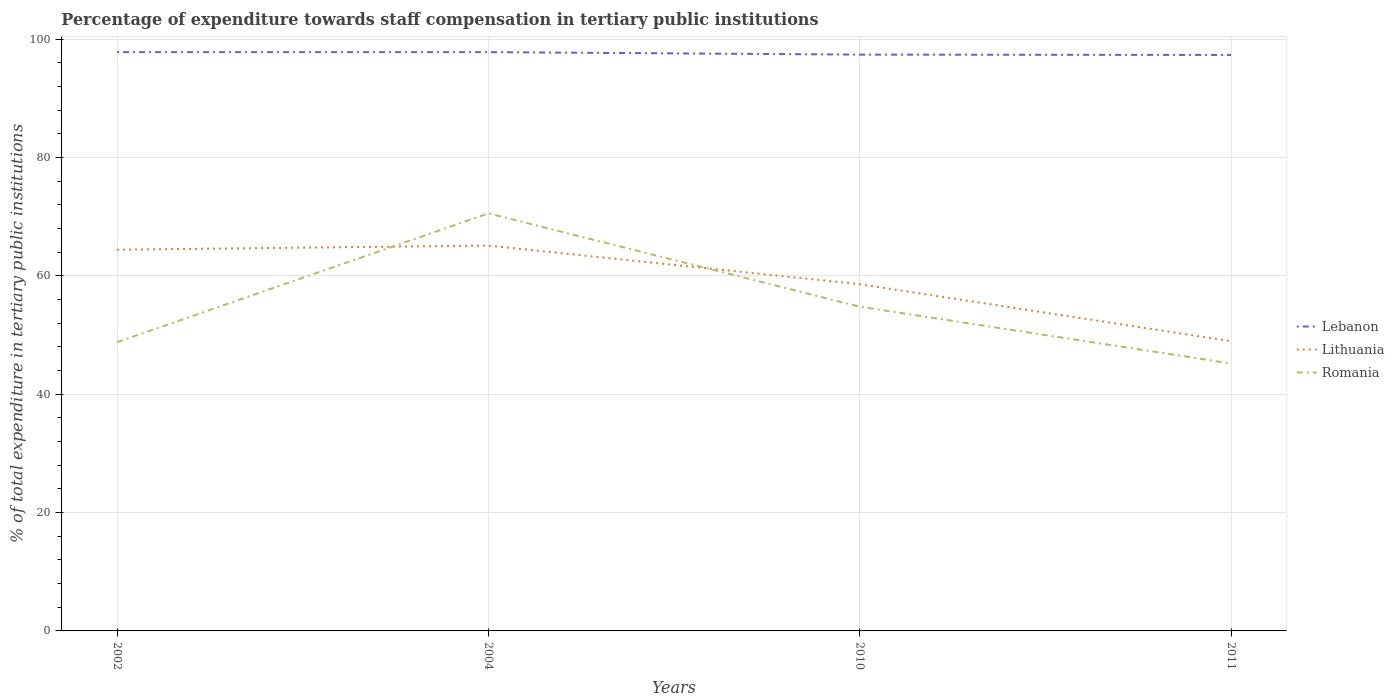Across all years, what is the maximum percentage of expenditure towards staff compensation in Lithuania?
Keep it short and to the point. 48.96. In which year was the percentage of expenditure towards staff compensation in Lithuania maximum?
Keep it short and to the point. 2011. What is the total percentage of expenditure towards staff compensation in Lithuania in the graph?
Offer a terse response. 16.15. What is the difference between the highest and the second highest percentage of expenditure towards staff compensation in Romania?
Keep it short and to the point. 25.36. What is the difference between the highest and the lowest percentage of expenditure towards staff compensation in Lithuania?
Offer a very short reply. 2. Is the percentage of expenditure towards staff compensation in Lithuania strictly greater than the percentage of expenditure towards staff compensation in Lebanon over the years?
Keep it short and to the point. Yes. How many lines are there?
Your response must be concise. 3. Are the values on the major ticks of Y-axis written in scientific E-notation?
Your response must be concise. No. Does the graph contain any zero values?
Your response must be concise. No. How many legend labels are there?
Offer a terse response. 3. What is the title of the graph?
Keep it short and to the point. Percentage of expenditure towards staff compensation in tertiary public institutions. What is the label or title of the Y-axis?
Your response must be concise. % of total expenditure in tertiary public institutions. What is the % of total expenditure in tertiary public institutions of Lebanon in 2002?
Make the answer very short. 97.8. What is the % of total expenditure in tertiary public institutions of Lithuania in 2002?
Provide a short and direct response. 64.41. What is the % of total expenditure in tertiary public institutions of Romania in 2002?
Give a very brief answer. 48.79. What is the % of total expenditure in tertiary public institutions of Lebanon in 2004?
Keep it short and to the point. 97.8. What is the % of total expenditure in tertiary public institutions in Lithuania in 2004?
Ensure brevity in your answer.  65.11. What is the % of total expenditure in tertiary public institutions in Romania in 2004?
Your answer should be compact. 70.56. What is the % of total expenditure in tertiary public institutions of Lebanon in 2010?
Keep it short and to the point. 97.38. What is the % of total expenditure in tertiary public institutions in Lithuania in 2010?
Make the answer very short. 58.59. What is the % of total expenditure in tertiary public institutions of Romania in 2010?
Provide a succinct answer. 54.79. What is the % of total expenditure in tertiary public institutions of Lebanon in 2011?
Make the answer very short. 97.32. What is the % of total expenditure in tertiary public institutions in Lithuania in 2011?
Provide a short and direct response. 48.96. What is the % of total expenditure in tertiary public institutions of Romania in 2011?
Your answer should be very brief. 45.19. Across all years, what is the maximum % of total expenditure in tertiary public institutions of Lebanon?
Provide a short and direct response. 97.8. Across all years, what is the maximum % of total expenditure in tertiary public institutions of Lithuania?
Your response must be concise. 65.11. Across all years, what is the maximum % of total expenditure in tertiary public institutions of Romania?
Give a very brief answer. 70.56. Across all years, what is the minimum % of total expenditure in tertiary public institutions in Lebanon?
Provide a short and direct response. 97.32. Across all years, what is the minimum % of total expenditure in tertiary public institutions of Lithuania?
Offer a very short reply. 48.96. Across all years, what is the minimum % of total expenditure in tertiary public institutions in Romania?
Provide a succinct answer. 45.19. What is the total % of total expenditure in tertiary public institutions in Lebanon in the graph?
Keep it short and to the point. 390.3. What is the total % of total expenditure in tertiary public institutions in Lithuania in the graph?
Provide a short and direct response. 237.07. What is the total % of total expenditure in tertiary public institutions in Romania in the graph?
Provide a short and direct response. 219.33. What is the difference between the % of total expenditure in tertiary public institutions of Lebanon in 2002 and that in 2004?
Offer a very short reply. -0. What is the difference between the % of total expenditure in tertiary public institutions of Lithuania in 2002 and that in 2004?
Offer a very short reply. -0.7. What is the difference between the % of total expenditure in tertiary public institutions in Romania in 2002 and that in 2004?
Give a very brief answer. -21.76. What is the difference between the % of total expenditure in tertiary public institutions in Lebanon in 2002 and that in 2010?
Your answer should be compact. 0.42. What is the difference between the % of total expenditure in tertiary public institutions in Lithuania in 2002 and that in 2010?
Keep it short and to the point. 5.82. What is the difference between the % of total expenditure in tertiary public institutions in Romania in 2002 and that in 2010?
Make the answer very short. -5.99. What is the difference between the % of total expenditure in tertiary public institutions in Lebanon in 2002 and that in 2011?
Provide a succinct answer. 0.47. What is the difference between the % of total expenditure in tertiary public institutions of Lithuania in 2002 and that in 2011?
Offer a terse response. 15.46. What is the difference between the % of total expenditure in tertiary public institutions of Romania in 2002 and that in 2011?
Offer a terse response. 3.6. What is the difference between the % of total expenditure in tertiary public institutions in Lebanon in 2004 and that in 2010?
Keep it short and to the point. 0.42. What is the difference between the % of total expenditure in tertiary public institutions of Lithuania in 2004 and that in 2010?
Your answer should be very brief. 6.52. What is the difference between the % of total expenditure in tertiary public institutions of Romania in 2004 and that in 2010?
Offer a very short reply. 15.77. What is the difference between the % of total expenditure in tertiary public institutions of Lebanon in 2004 and that in 2011?
Offer a very short reply. 0.47. What is the difference between the % of total expenditure in tertiary public institutions of Lithuania in 2004 and that in 2011?
Give a very brief answer. 16.15. What is the difference between the % of total expenditure in tertiary public institutions in Romania in 2004 and that in 2011?
Your answer should be compact. 25.36. What is the difference between the % of total expenditure in tertiary public institutions of Lebanon in 2010 and that in 2011?
Ensure brevity in your answer.  0.06. What is the difference between the % of total expenditure in tertiary public institutions in Lithuania in 2010 and that in 2011?
Keep it short and to the point. 9.63. What is the difference between the % of total expenditure in tertiary public institutions in Romania in 2010 and that in 2011?
Keep it short and to the point. 9.6. What is the difference between the % of total expenditure in tertiary public institutions in Lebanon in 2002 and the % of total expenditure in tertiary public institutions in Lithuania in 2004?
Give a very brief answer. 32.69. What is the difference between the % of total expenditure in tertiary public institutions in Lebanon in 2002 and the % of total expenditure in tertiary public institutions in Romania in 2004?
Your answer should be very brief. 27.24. What is the difference between the % of total expenditure in tertiary public institutions in Lithuania in 2002 and the % of total expenditure in tertiary public institutions in Romania in 2004?
Provide a short and direct response. -6.15. What is the difference between the % of total expenditure in tertiary public institutions of Lebanon in 2002 and the % of total expenditure in tertiary public institutions of Lithuania in 2010?
Keep it short and to the point. 39.21. What is the difference between the % of total expenditure in tertiary public institutions of Lebanon in 2002 and the % of total expenditure in tertiary public institutions of Romania in 2010?
Ensure brevity in your answer.  43.01. What is the difference between the % of total expenditure in tertiary public institutions of Lithuania in 2002 and the % of total expenditure in tertiary public institutions of Romania in 2010?
Your response must be concise. 9.62. What is the difference between the % of total expenditure in tertiary public institutions in Lebanon in 2002 and the % of total expenditure in tertiary public institutions in Lithuania in 2011?
Ensure brevity in your answer.  48.84. What is the difference between the % of total expenditure in tertiary public institutions in Lebanon in 2002 and the % of total expenditure in tertiary public institutions in Romania in 2011?
Your answer should be compact. 52.6. What is the difference between the % of total expenditure in tertiary public institutions in Lithuania in 2002 and the % of total expenditure in tertiary public institutions in Romania in 2011?
Offer a very short reply. 19.22. What is the difference between the % of total expenditure in tertiary public institutions in Lebanon in 2004 and the % of total expenditure in tertiary public institutions in Lithuania in 2010?
Ensure brevity in your answer.  39.21. What is the difference between the % of total expenditure in tertiary public institutions in Lebanon in 2004 and the % of total expenditure in tertiary public institutions in Romania in 2010?
Make the answer very short. 43.01. What is the difference between the % of total expenditure in tertiary public institutions of Lithuania in 2004 and the % of total expenditure in tertiary public institutions of Romania in 2010?
Your answer should be compact. 10.32. What is the difference between the % of total expenditure in tertiary public institutions in Lebanon in 2004 and the % of total expenditure in tertiary public institutions in Lithuania in 2011?
Make the answer very short. 48.84. What is the difference between the % of total expenditure in tertiary public institutions of Lebanon in 2004 and the % of total expenditure in tertiary public institutions of Romania in 2011?
Keep it short and to the point. 52.6. What is the difference between the % of total expenditure in tertiary public institutions in Lithuania in 2004 and the % of total expenditure in tertiary public institutions in Romania in 2011?
Keep it short and to the point. 19.92. What is the difference between the % of total expenditure in tertiary public institutions in Lebanon in 2010 and the % of total expenditure in tertiary public institutions in Lithuania in 2011?
Provide a succinct answer. 48.43. What is the difference between the % of total expenditure in tertiary public institutions in Lebanon in 2010 and the % of total expenditure in tertiary public institutions in Romania in 2011?
Offer a very short reply. 52.19. What is the difference between the % of total expenditure in tertiary public institutions in Lithuania in 2010 and the % of total expenditure in tertiary public institutions in Romania in 2011?
Provide a short and direct response. 13.4. What is the average % of total expenditure in tertiary public institutions of Lebanon per year?
Keep it short and to the point. 97.57. What is the average % of total expenditure in tertiary public institutions of Lithuania per year?
Offer a very short reply. 59.27. What is the average % of total expenditure in tertiary public institutions in Romania per year?
Provide a succinct answer. 54.83. In the year 2002, what is the difference between the % of total expenditure in tertiary public institutions of Lebanon and % of total expenditure in tertiary public institutions of Lithuania?
Give a very brief answer. 33.38. In the year 2002, what is the difference between the % of total expenditure in tertiary public institutions in Lebanon and % of total expenditure in tertiary public institutions in Romania?
Your response must be concise. 49. In the year 2002, what is the difference between the % of total expenditure in tertiary public institutions of Lithuania and % of total expenditure in tertiary public institutions of Romania?
Offer a very short reply. 15.62. In the year 2004, what is the difference between the % of total expenditure in tertiary public institutions of Lebanon and % of total expenditure in tertiary public institutions of Lithuania?
Your response must be concise. 32.69. In the year 2004, what is the difference between the % of total expenditure in tertiary public institutions of Lebanon and % of total expenditure in tertiary public institutions of Romania?
Offer a very short reply. 27.24. In the year 2004, what is the difference between the % of total expenditure in tertiary public institutions in Lithuania and % of total expenditure in tertiary public institutions in Romania?
Provide a short and direct response. -5.45. In the year 2010, what is the difference between the % of total expenditure in tertiary public institutions of Lebanon and % of total expenditure in tertiary public institutions of Lithuania?
Offer a very short reply. 38.79. In the year 2010, what is the difference between the % of total expenditure in tertiary public institutions in Lebanon and % of total expenditure in tertiary public institutions in Romania?
Provide a succinct answer. 42.59. In the year 2010, what is the difference between the % of total expenditure in tertiary public institutions of Lithuania and % of total expenditure in tertiary public institutions of Romania?
Offer a very short reply. 3.8. In the year 2011, what is the difference between the % of total expenditure in tertiary public institutions in Lebanon and % of total expenditure in tertiary public institutions in Lithuania?
Offer a terse response. 48.37. In the year 2011, what is the difference between the % of total expenditure in tertiary public institutions in Lebanon and % of total expenditure in tertiary public institutions in Romania?
Ensure brevity in your answer.  52.13. In the year 2011, what is the difference between the % of total expenditure in tertiary public institutions in Lithuania and % of total expenditure in tertiary public institutions in Romania?
Your answer should be compact. 3.76. What is the ratio of the % of total expenditure in tertiary public institutions of Lebanon in 2002 to that in 2004?
Provide a short and direct response. 1. What is the ratio of the % of total expenditure in tertiary public institutions of Lithuania in 2002 to that in 2004?
Offer a terse response. 0.99. What is the ratio of the % of total expenditure in tertiary public institutions in Romania in 2002 to that in 2004?
Offer a very short reply. 0.69. What is the ratio of the % of total expenditure in tertiary public institutions of Lebanon in 2002 to that in 2010?
Give a very brief answer. 1. What is the ratio of the % of total expenditure in tertiary public institutions of Lithuania in 2002 to that in 2010?
Your response must be concise. 1.1. What is the ratio of the % of total expenditure in tertiary public institutions in Romania in 2002 to that in 2010?
Offer a very short reply. 0.89. What is the ratio of the % of total expenditure in tertiary public institutions of Lebanon in 2002 to that in 2011?
Provide a short and direct response. 1. What is the ratio of the % of total expenditure in tertiary public institutions of Lithuania in 2002 to that in 2011?
Provide a succinct answer. 1.32. What is the ratio of the % of total expenditure in tertiary public institutions in Romania in 2002 to that in 2011?
Your response must be concise. 1.08. What is the ratio of the % of total expenditure in tertiary public institutions of Lebanon in 2004 to that in 2010?
Give a very brief answer. 1. What is the ratio of the % of total expenditure in tertiary public institutions in Lithuania in 2004 to that in 2010?
Offer a very short reply. 1.11. What is the ratio of the % of total expenditure in tertiary public institutions of Romania in 2004 to that in 2010?
Keep it short and to the point. 1.29. What is the ratio of the % of total expenditure in tertiary public institutions in Lithuania in 2004 to that in 2011?
Ensure brevity in your answer.  1.33. What is the ratio of the % of total expenditure in tertiary public institutions of Romania in 2004 to that in 2011?
Give a very brief answer. 1.56. What is the ratio of the % of total expenditure in tertiary public institutions in Lithuania in 2010 to that in 2011?
Offer a very short reply. 1.2. What is the ratio of the % of total expenditure in tertiary public institutions in Romania in 2010 to that in 2011?
Offer a very short reply. 1.21. What is the difference between the highest and the second highest % of total expenditure in tertiary public institutions of Lithuania?
Keep it short and to the point. 0.7. What is the difference between the highest and the second highest % of total expenditure in tertiary public institutions of Romania?
Keep it short and to the point. 15.77. What is the difference between the highest and the lowest % of total expenditure in tertiary public institutions in Lebanon?
Ensure brevity in your answer.  0.47. What is the difference between the highest and the lowest % of total expenditure in tertiary public institutions of Lithuania?
Provide a succinct answer. 16.15. What is the difference between the highest and the lowest % of total expenditure in tertiary public institutions of Romania?
Your response must be concise. 25.36. 